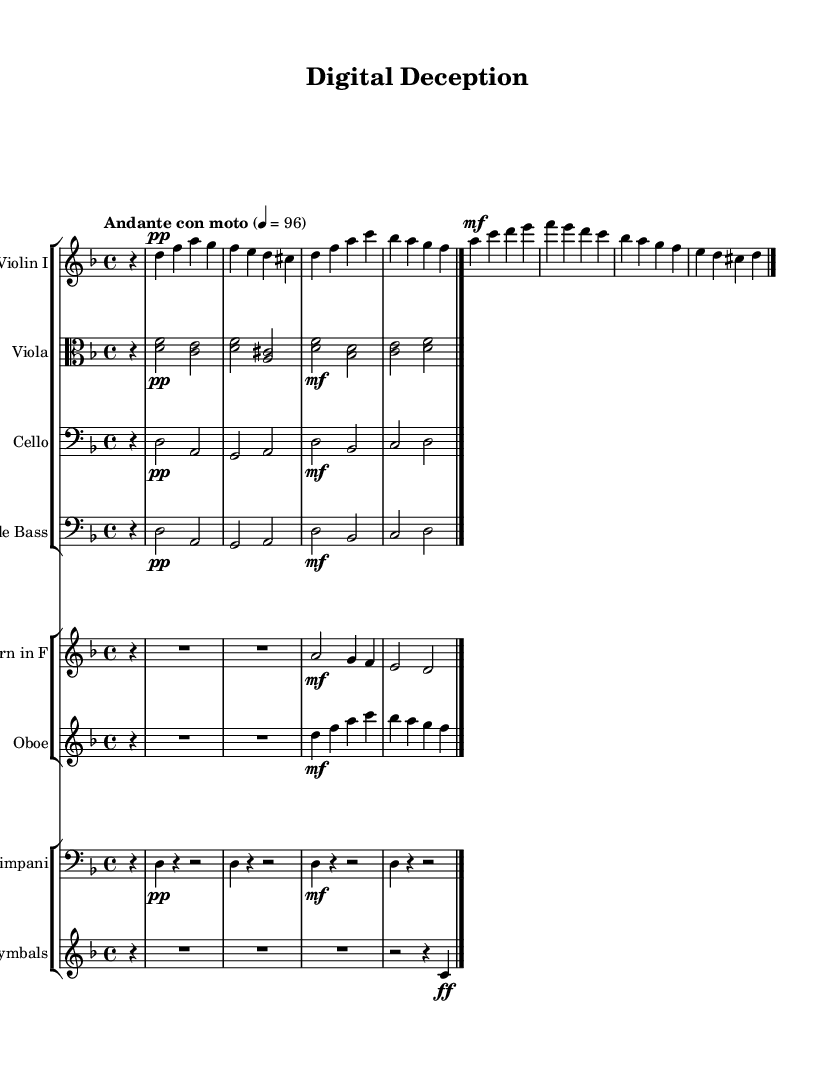What is the key signature of this music? The key signature indicates one flat, which corresponds to the key of D minor, as it has one flat noted (the B flat).
Answer: D minor What is the time signature used in the score? The time signature shown in the music is 4/4, meaning there are four beats in a measure, and the quarter note gets one beat.
Answer: 4/4 What is the tempo marking for this piece? The tempo marking at the beginning of the score is "Andante con moto," which indicates a moderate walking pace with some motion.
Answer: Andante con moto How many measures are there in the violin part? The violin part is written with a total of eight measures, counted from the beginning until the final bar line.
Answer: Eight Which instruments are in the first staff group? The first staff group contains Violin I, Viola, Cello, and Double Bass as their names are indicated at the beginning of each staff.
Answer: Violin I, Viola, Cello, Double Bass What dynamic marking is indicated for the cello part at the start? The cello part begins with a dynamic marking of pianissimo (pp), indicating to play very softly.
Answer: Pianissimo What is the significance of the cymbals in this score? The cymbals create accents and impact, typically used to emphasize dramatic climaxes or transitions in soundtracks.
Answer: Emphasize dramatic tension 